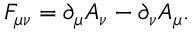<formula> <loc_0><loc_0><loc_500><loc_500>F _ { \mu \nu } = \partial _ { \mu } A _ { \nu } - \partial _ { \nu } A _ { \mu } .</formula> 